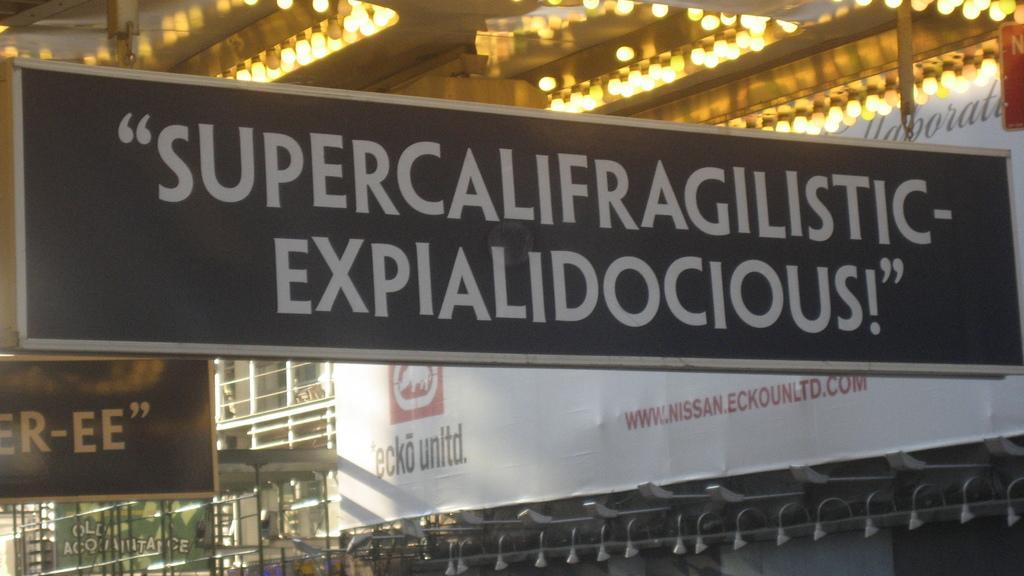Can you describe this image briefly? This is a building and here we can see hoardings, banners and lights. 